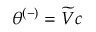Convert formula to latex. <formula><loc_0><loc_0><loc_500><loc_500>\theta ^ { ( - ) } = \widetilde { V } c</formula> 